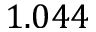Convert formula to latex. <formula><loc_0><loc_0><loc_500><loc_500>1 . 0 4 4</formula> 